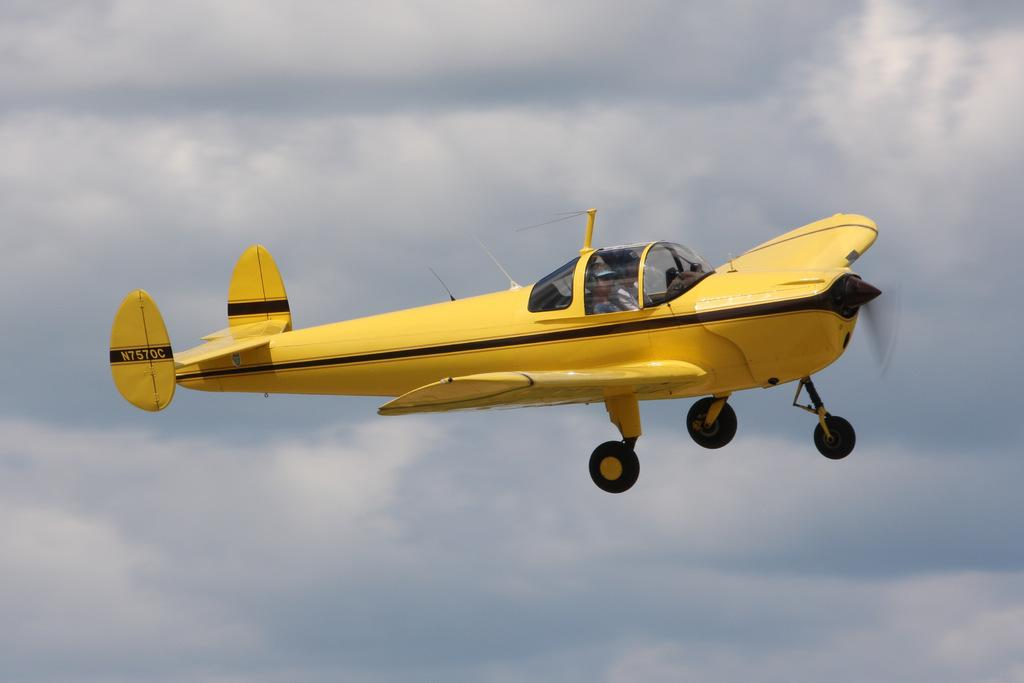What is the main subject of the image? The main subject of the image is an aeroplane. What colors are used for the aeroplane? The aeroplane is in yellow and black color. What colors are used for the sky in the image? The sky is in white and blue color. What type of mint can be seen growing near the aeroplane in the image? There is no mint present in the image; the focus is on the aeroplane and the sky. 